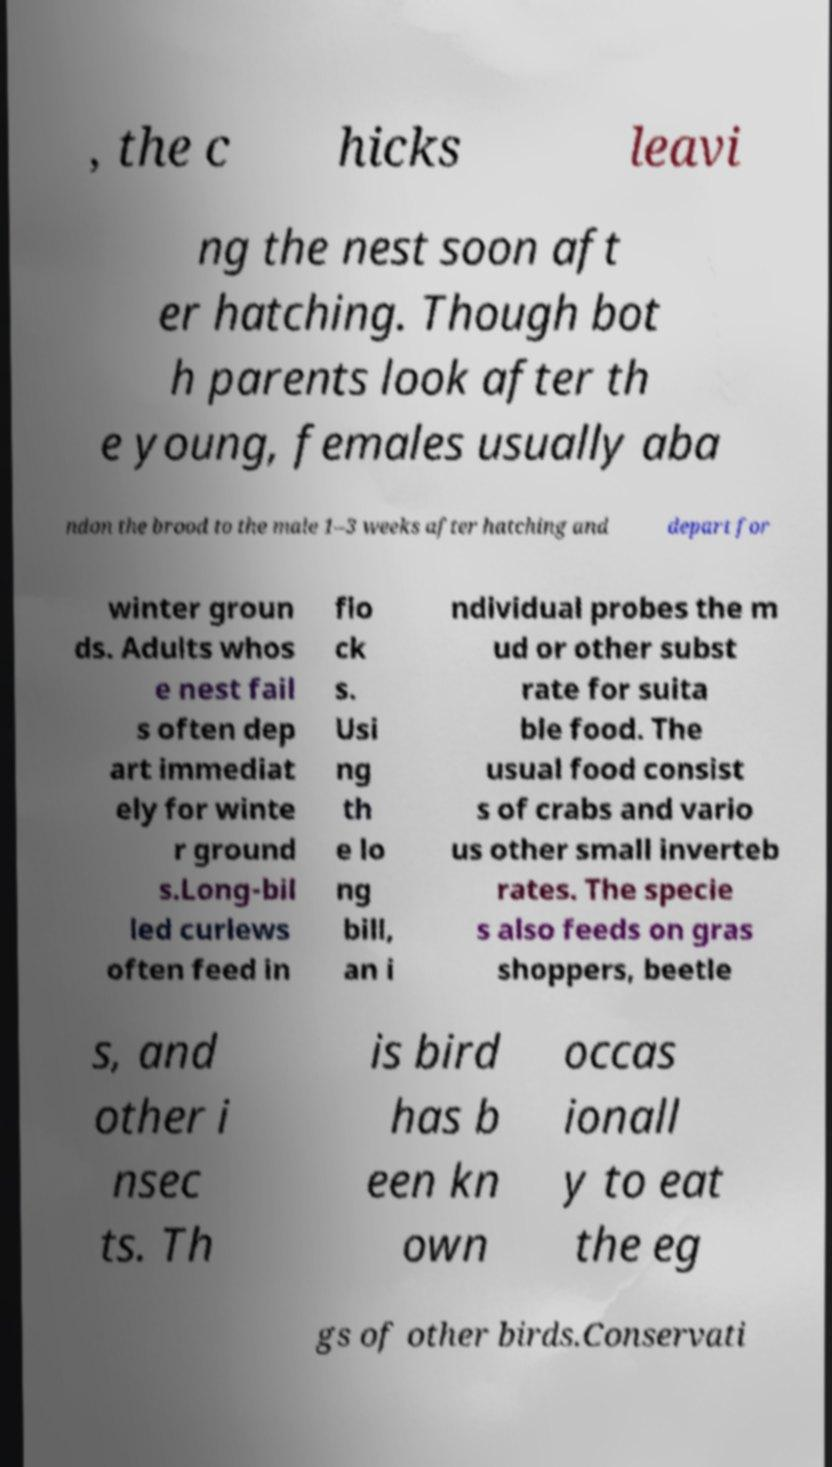I need the written content from this picture converted into text. Can you do that? , the c hicks leavi ng the nest soon aft er hatching. Though bot h parents look after th e young, females usually aba ndon the brood to the male 1–3 weeks after hatching and depart for winter groun ds. Adults whos e nest fail s often dep art immediat ely for winte r ground s.Long-bil led curlews often feed in flo ck s. Usi ng th e lo ng bill, an i ndividual probes the m ud or other subst rate for suita ble food. The usual food consist s of crabs and vario us other small inverteb rates. The specie s also feeds on gras shoppers, beetle s, and other i nsec ts. Th is bird has b een kn own occas ionall y to eat the eg gs of other birds.Conservati 